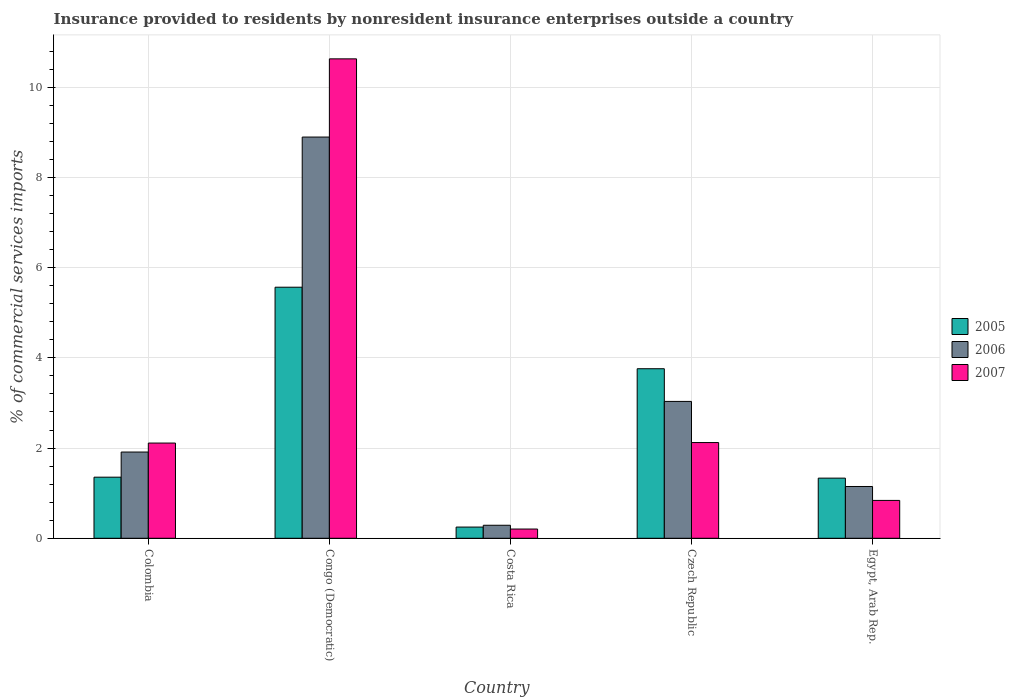How many groups of bars are there?
Provide a succinct answer. 5. Are the number of bars per tick equal to the number of legend labels?
Offer a very short reply. Yes. Are the number of bars on each tick of the X-axis equal?
Offer a very short reply. Yes. How many bars are there on the 5th tick from the right?
Provide a succinct answer. 3. What is the label of the 4th group of bars from the left?
Your answer should be compact. Czech Republic. In how many cases, is the number of bars for a given country not equal to the number of legend labels?
Your answer should be compact. 0. What is the Insurance provided to residents in 2005 in Congo (Democratic)?
Provide a short and direct response. 5.57. Across all countries, what is the maximum Insurance provided to residents in 2007?
Keep it short and to the point. 10.63. Across all countries, what is the minimum Insurance provided to residents in 2006?
Your answer should be very brief. 0.29. In which country was the Insurance provided to residents in 2005 maximum?
Keep it short and to the point. Congo (Democratic). What is the total Insurance provided to residents in 2007 in the graph?
Provide a short and direct response. 15.9. What is the difference between the Insurance provided to residents in 2007 in Congo (Democratic) and that in Egypt, Arab Rep.?
Provide a short and direct response. 9.79. What is the difference between the Insurance provided to residents in 2006 in Colombia and the Insurance provided to residents in 2005 in Czech Republic?
Offer a very short reply. -1.85. What is the average Insurance provided to residents in 2005 per country?
Offer a very short reply. 2.45. What is the difference between the Insurance provided to residents of/in 2006 and Insurance provided to residents of/in 2007 in Czech Republic?
Ensure brevity in your answer.  0.91. In how many countries, is the Insurance provided to residents in 2007 greater than 4 %?
Provide a succinct answer. 1. What is the ratio of the Insurance provided to residents in 2005 in Costa Rica to that in Egypt, Arab Rep.?
Keep it short and to the point. 0.19. Is the Insurance provided to residents in 2006 in Congo (Democratic) less than that in Czech Republic?
Ensure brevity in your answer.  No. Is the difference between the Insurance provided to residents in 2006 in Costa Rica and Egypt, Arab Rep. greater than the difference between the Insurance provided to residents in 2007 in Costa Rica and Egypt, Arab Rep.?
Offer a terse response. No. What is the difference between the highest and the second highest Insurance provided to residents in 2006?
Provide a short and direct response. 6.98. What is the difference between the highest and the lowest Insurance provided to residents in 2007?
Make the answer very short. 10.42. In how many countries, is the Insurance provided to residents in 2005 greater than the average Insurance provided to residents in 2005 taken over all countries?
Your response must be concise. 2. What does the 3rd bar from the left in Congo (Democratic) represents?
Provide a short and direct response. 2007. What does the 3rd bar from the right in Czech Republic represents?
Keep it short and to the point. 2005. Is it the case that in every country, the sum of the Insurance provided to residents in 2006 and Insurance provided to residents in 2005 is greater than the Insurance provided to residents in 2007?
Make the answer very short. Yes. Are all the bars in the graph horizontal?
Offer a very short reply. No. How many countries are there in the graph?
Offer a terse response. 5. How many legend labels are there?
Provide a short and direct response. 3. What is the title of the graph?
Ensure brevity in your answer.  Insurance provided to residents by nonresident insurance enterprises outside a country. Does "1973" appear as one of the legend labels in the graph?
Offer a very short reply. No. What is the label or title of the X-axis?
Offer a very short reply. Country. What is the label or title of the Y-axis?
Your answer should be very brief. % of commercial services imports. What is the % of commercial services imports in 2005 in Colombia?
Your answer should be compact. 1.35. What is the % of commercial services imports of 2006 in Colombia?
Your answer should be very brief. 1.91. What is the % of commercial services imports in 2007 in Colombia?
Provide a succinct answer. 2.11. What is the % of commercial services imports of 2005 in Congo (Democratic)?
Your answer should be compact. 5.57. What is the % of commercial services imports in 2006 in Congo (Democratic)?
Provide a short and direct response. 8.89. What is the % of commercial services imports in 2007 in Congo (Democratic)?
Keep it short and to the point. 10.63. What is the % of commercial services imports of 2005 in Costa Rica?
Your answer should be compact. 0.25. What is the % of commercial services imports of 2006 in Costa Rica?
Keep it short and to the point. 0.29. What is the % of commercial services imports of 2007 in Costa Rica?
Your answer should be very brief. 0.2. What is the % of commercial services imports in 2005 in Czech Republic?
Your answer should be very brief. 3.76. What is the % of commercial services imports in 2006 in Czech Republic?
Offer a terse response. 3.03. What is the % of commercial services imports in 2007 in Czech Republic?
Make the answer very short. 2.12. What is the % of commercial services imports of 2005 in Egypt, Arab Rep.?
Your answer should be very brief. 1.33. What is the % of commercial services imports in 2006 in Egypt, Arab Rep.?
Offer a terse response. 1.15. What is the % of commercial services imports of 2007 in Egypt, Arab Rep.?
Offer a terse response. 0.84. Across all countries, what is the maximum % of commercial services imports of 2005?
Your response must be concise. 5.57. Across all countries, what is the maximum % of commercial services imports in 2006?
Your answer should be very brief. 8.89. Across all countries, what is the maximum % of commercial services imports in 2007?
Your answer should be compact. 10.63. Across all countries, what is the minimum % of commercial services imports of 2005?
Your answer should be very brief. 0.25. Across all countries, what is the minimum % of commercial services imports in 2006?
Provide a short and direct response. 0.29. Across all countries, what is the minimum % of commercial services imports of 2007?
Offer a very short reply. 0.2. What is the total % of commercial services imports of 2005 in the graph?
Your response must be concise. 12.26. What is the total % of commercial services imports of 2006 in the graph?
Give a very brief answer. 15.28. What is the total % of commercial services imports in 2007 in the graph?
Your answer should be compact. 15.9. What is the difference between the % of commercial services imports in 2005 in Colombia and that in Congo (Democratic)?
Ensure brevity in your answer.  -4.21. What is the difference between the % of commercial services imports of 2006 in Colombia and that in Congo (Democratic)?
Give a very brief answer. -6.98. What is the difference between the % of commercial services imports in 2007 in Colombia and that in Congo (Democratic)?
Your response must be concise. -8.52. What is the difference between the % of commercial services imports in 2005 in Colombia and that in Costa Rica?
Your answer should be very brief. 1.11. What is the difference between the % of commercial services imports of 2006 in Colombia and that in Costa Rica?
Keep it short and to the point. 1.62. What is the difference between the % of commercial services imports in 2007 in Colombia and that in Costa Rica?
Your answer should be very brief. 1.91. What is the difference between the % of commercial services imports in 2005 in Colombia and that in Czech Republic?
Make the answer very short. -2.4. What is the difference between the % of commercial services imports of 2006 in Colombia and that in Czech Republic?
Give a very brief answer. -1.12. What is the difference between the % of commercial services imports of 2007 in Colombia and that in Czech Republic?
Provide a short and direct response. -0.01. What is the difference between the % of commercial services imports in 2005 in Colombia and that in Egypt, Arab Rep.?
Offer a very short reply. 0.02. What is the difference between the % of commercial services imports of 2006 in Colombia and that in Egypt, Arab Rep.?
Offer a terse response. 0.76. What is the difference between the % of commercial services imports in 2007 in Colombia and that in Egypt, Arab Rep.?
Your answer should be very brief. 1.27. What is the difference between the % of commercial services imports in 2005 in Congo (Democratic) and that in Costa Rica?
Provide a succinct answer. 5.32. What is the difference between the % of commercial services imports of 2006 in Congo (Democratic) and that in Costa Rica?
Ensure brevity in your answer.  8.6. What is the difference between the % of commercial services imports of 2007 in Congo (Democratic) and that in Costa Rica?
Provide a short and direct response. 10.42. What is the difference between the % of commercial services imports in 2005 in Congo (Democratic) and that in Czech Republic?
Ensure brevity in your answer.  1.81. What is the difference between the % of commercial services imports of 2006 in Congo (Democratic) and that in Czech Republic?
Your answer should be compact. 5.86. What is the difference between the % of commercial services imports of 2007 in Congo (Democratic) and that in Czech Republic?
Make the answer very short. 8.51. What is the difference between the % of commercial services imports in 2005 in Congo (Democratic) and that in Egypt, Arab Rep.?
Provide a short and direct response. 4.23. What is the difference between the % of commercial services imports of 2006 in Congo (Democratic) and that in Egypt, Arab Rep.?
Provide a succinct answer. 7.75. What is the difference between the % of commercial services imports in 2007 in Congo (Democratic) and that in Egypt, Arab Rep.?
Your response must be concise. 9.79. What is the difference between the % of commercial services imports of 2005 in Costa Rica and that in Czech Republic?
Keep it short and to the point. -3.51. What is the difference between the % of commercial services imports of 2006 in Costa Rica and that in Czech Republic?
Make the answer very short. -2.75. What is the difference between the % of commercial services imports of 2007 in Costa Rica and that in Czech Republic?
Ensure brevity in your answer.  -1.92. What is the difference between the % of commercial services imports in 2005 in Costa Rica and that in Egypt, Arab Rep.?
Give a very brief answer. -1.08. What is the difference between the % of commercial services imports in 2006 in Costa Rica and that in Egypt, Arab Rep.?
Your response must be concise. -0.86. What is the difference between the % of commercial services imports of 2007 in Costa Rica and that in Egypt, Arab Rep.?
Keep it short and to the point. -0.63. What is the difference between the % of commercial services imports in 2005 in Czech Republic and that in Egypt, Arab Rep.?
Make the answer very short. 2.42. What is the difference between the % of commercial services imports of 2006 in Czech Republic and that in Egypt, Arab Rep.?
Offer a very short reply. 1.89. What is the difference between the % of commercial services imports in 2007 in Czech Republic and that in Egypt, Arab Rep.?
Ensure brevity in your answer.  1.28. What is the difference between the % of commercial services imports of 2005 in Colombia and the % of commercial services imports of 2006 in Congo (Democratic)?
Give a very brief answer. -7.54. What is the difference between the % of commercial services imports in 2005 in Colombia and the % of commercial services imports in 2007 in Congo (Democratic)?
Make the answer very short. -9.27. What is the difference between the % of commercial services imports in 2006 in Colombia and the % of commercial services imports in 2007 in Congo (Democratic)?
Your response must be concise. -8.72. What is the difference between the % of commercial services imports of 2005 in Colombia and the % of commercial services imports of 2006 in Costa Rica?
Keep it short and to the point. 1.07. What is the difference between the % of commercial services imports of 2005 in Colombia and the % of commercial services imports of 2007 in Costa Rica?
Provide a short and direct response. 1.15. What is the difference between the % of commercial services imports of 2006 in Colombia and the % of commercial services imports of 2007 in Costa Rica?
Make the answer very short. 1.71. What is the difference between the % of commercial services imports of 2005 in Colombia and the % of commercial services imports of 2006 in Czech Republic?
Provide a short and direct response. -1.68. What is the difference between the % of commercial services imports in 2005 in Colombia and the % of commercial services imports in 2007 in Czech Republic?
Offer a very short reply. -0.77. What is the difference between the % of commercial services imports of 2006 in Colombia and the % of commercial services imports of 2007 in Czech Republic?
Offer a very short reply. -0.21. What is the difference between the % of commercial services imports of 2005 in Colombia and the % of commercial services imports of 2006 in Egypt, Arab Rep.?
Keep it short and to the point. 0.21. What is the difference between the % of commercial services imports of 2005 in Colombia and the % of commercial services imports of 2007 in Egypt, Arab Rep.?
Ensure brevity in your answer.  0.52. What is the difference between the % of commercial services imports of 2006 in Colombia and the % of commercial services imports of 2007 in Egypt, Arab Rep.?
Provide a short and direct response. 1.07. What is the difference between the % of commercial services imports of 2005 in Congo (Democratic) and the % of commercial services imports of 2006 in Costa Rica?
Your response must be concise. 5.28. What is the difference between the % of commercial services imports in 2005 in Congo (Democratic) and the % of commercial services imports in 2007 in Costa Rica?
Make the answer very short. 5.36. What is the difference between the % of commercial services imports in 2006 in Congo (Democratic) and the % of commercial services imports in 2007 in Costa Rica?
Give a very brief answer. 8.69. What is the difference between the % of commercial services imports in 2005 in Congo (Democratic) and the % of commercial services imports in 2006 in Czech Republic?
Your answer should be very brief. 2.53. What is the difference between the % of commercial services imports in 2005 in Congo (Democratic) and the % of commercial services imports in 2007 in Czech Republic?
Keep it short and to the point. 3.44. What is the difference between the % of commercial services imports in 2006 in Congo (Democratic) and the % of commercial services imports in 2007 in Czech Republic?
Provide a succinct answer. 6.77. What is the difference between the % of commercial services imports of 2005 in Congo (Democratic) and the % of commercial services imports of 2006 in Egypt, Arab Rep.?
Your response must be concise. 4.42. What is the difference between the % of commercial services imports of 2005 in Congo (Democratic) and the % of commercial services imports of 2007 in Egypt, Arab Rep.?
Your response must be concise. 4.73. What is the difference between the % of commercial services imports of 2006 in Congo (Democratic) and the % of commercial services imports of 2007 in Egypt, Arab Rep.?
Your answer should be very brief. 8.05. What is the difference between the % of commercial services imports in 2005 in Costa Rica and the % of commercial services imports in 2006 in Czech Republic?
Give a very brief answer. -2.79. What is the difference between the % of commercial services imports of 2005 in Costa Rica and the % of commercial services imports of 2007 in Czech Republic?
Your answer should be compact. -1.87. What is the difference between the % of commercial services imports of 2006 in Costa Rica and the % of commercial services imports of 2007 in Czech Republic?
Provide a short and direct response. -1.83. What is the difference between the % of commercial services imports in 2005 in Costa Rica and the % of commercial services imports in 2006 in Egypt, Arab Rep.?
Your answer should be compact. -0.9. What is the difference between the % of commercial services imports of 2005 in Costa Rica and the % of commercial services imports of 2007 in Egypt, Arab Rep.?
Provide a succinct answer. -0.59. What is the difference between the % of commercial services imports of 2006 in Costa Rica and the % of commercial services imports of 2007 in Egypt, Arab Rep.?
Give a very brief answer. -0.55. What is the difference between the % of commercial services imports of 2005 in Czech Republic and the % of commercial services imports of 2006 in Egypt, Arab Rep.?
Keep it short and to the point. 2.61. What is the difference between the % of commercial services imports of 2005 in Czech Republic and the % of commercial services imports of 2007 in Egypt, Arab Rep.?
Your answer should be very brief. 2.92. What is the difference between the % of commercial services imports in 2006 in Czech Republic and the % of commercial services imports in 2007 in Egypt, Arab Rep.?
Keep it short and to the point. 2.19. What is the average % of commercial services imports in 2005 per country?
Your answer should be very brief. 2.45. What is the average % of commercial services imports of 2006 per country?
Offer a terse response. 3.06. What is the average % of commercial services imports in 2007 per country?
Keep it short and to the point. 3.18. What is the difference between the % of commercial services imports in 2005 and % of commercial services imports in 2006 in Colombia?
Your answer should be very brief. -0.56. What is the difference between the % of commercial services imports in 2005 and % of commercial services imports in 2007 in Colombia?
Ensure brevity in your answer.  -0.76. What is the difference between the % of commercial services imports of 2006 and % of commercial services imports of 2007 in Colombia?
Ensure brevity in your answer.  -0.2. What is the difference between the % of commercial services imports of 2005 and % of commercial services imports of 2006 in Congo (Democratic)?
Provide a succinct answer. -3.33. What is the difference between the % of commercial services imports in 2005 and % of commercial services imports in 2007 in Congo (Democratic)?
Make the answer very short. -5.06. What is the difference between the % of commercial services imports in 2006 and % of commercial services imports in 2007 in Congo (Democratic)?
Give a very brief answer. -1.73. What is the difference between the % of commercial services imports in 2005 and % of commercial services imports in 2006 in Costa Rica?
Provide a short and direct response. -0.04. What is the difference between the % of commercial services imports in 2005 and % of commercial services imports in 2007 in Costa Rica?
Keep it short and to the point. 0.04. What is the difference between the % of commercial services imports of 2006 and % of commercial services imports of 2007 in Costa Rica?
Offer a very short reply. 0.08. What is the difference between the % of commercial services imports in 2005 and % of commercial services imports in 2006 in Czech Republic?
Your answer should be compact. 0.72. What is the difference between the % of commercial services imports in 2005 and % of commercial services imports in 2007 in Czech Republic?
Ensure brevity in your answer.  1.64. What is the difference between the % of commercial services imports of 2006 and % of commercial services imports of 2007 in Czech Republic?
Offer a terse response. 0.91. What is the difference between the % of commercial services imports in 2005 and % of commercial services imports in 2006 in Egypt, Arab Rep.?
Make the answer very short. 0.19. What is the difference between the % of commercial services imports of 2005 and % of commercial services imports of 2007 in Egypt, Arab Rep.?
Offer a very short reply. 0.49. What is the difference between the % of commercial services imports of 2006 and % of commercial services imports of 2007 in Egypt, Arab Rep.?
Give a very brief answer. 0.31. What is the ratio of the % of commercial services imports in 2005 in Colombia to that in Congo (Democratic)?
Your answer should be very brief. 0.24. What is the ratio of the % of commercial services imports in 2006 in Colombia to that in Congo (Democratic)?
Your answer should be compact. 0.21. What is the ratio of the % of commercial services imports of 2007 in Colombia to that in Congo (Democratic)?
Your answer should be very brief. 0.2. What is the ratio of the % of commercial services imports of 2005 in Colombia to that in Costa Rica?
Make the answer very short. 5.45. What is the ratio of the % of commercial services imports in 2006 in Colombia to that in Costa Rica?
Your answer should be compact. 6.62. What is the ratio of the % of commercial services imports in 2007 in Colombia to that in Costa Rica?
Make the answer very short. 10.3. What is the ratio of the % of commercial services imports of 2005 in Colombia to that in Czech Republic?
Keep it short and to the point. 0.36. What is the ratio of the % of commercial services imports in 2006 in Colombia to that in Czech Republic?
Keep it short and to the point. 0.63. What is the ratio of the % of commercial services imports in 2007 in Colombia to that in Czech Republic?
Provide a succinct answer. 0.99. What is the ratio of the % of commercial services imports in 2005 in Colombia to that in Egypt, Arab Rep.?
Your answer should be compact. 1.02. What is the ratio of the % of commercial services imports in 2006 in Colombia to that in Egypt, Arab Rep.?
Your answer should be very brief. 1.67. What is the ratio of the % of commercial services imports in 2007 in Colombia to that in Egypt, Arab Rep.?
Keep it short and to the point. 2.51. What is the ratio of the % of commercial services imports in 2005 in Congo (Democratic) to that in Costa Rica?
Your response must be concise. 22.41. What is the ratio of the % of commercial services imports in 2006 in Congo (Democratic) to that in Costa Rica?
Offer a terse response. 30.8. What is the ratio of the % of commercial services imports in 2007 in Congo (Democratic) to that in Costa Rica?
Your response must be concise. 51.87. What is the ratio of the % of commercial services imports of 2005 in Congo (Democratic) to that in Czech Republic?
Offer a very short reply. 1.48. What is the ratio of the % of commercial services imports of 2006 in Congo (Democratic) to that in Czech Republic?
Give a very brief answer. 2.93. What is the ratio of the % of commercial services imports of 2007 in Congo (Democratic) to that in Czech Republic?
Offer a terse response. 5.01. What is the ratio of the % of commercial services imports in 2005 in Congo (Democratic) to that in Egypt, Arab Rep.?
Keep it short and to the point. 4.17. What is the ratio of the % of commercial services imports of 2006 in Congo (Democratic) to that in Egypt, Arab Rep.?
Your response must be concise. 7.75. What is the ratio of the % of commercial services imports in 2007 in Congo (Democratic) to that in Egypt, Arab Rep.?
Provide a succinct answer. 12.66. What is the ratio of the % of commercial services imports of 2005 in Costa Rica to that in Czech Republic?
Keep it short and to the point. 0.07. What is the ratio of the % of commercial services imports in 2006 in Costa Rica to that in Czech Republic?
Your answer should be compact. 0.1. What is the ratio of the % of commercial services imports in 2007 in Costa Rica to that in Czech Republic?
Offer a very short reply. 0.1. What is the ratio of the % of commercial services imports in 2005 in Costa Rica to that in Egypt, Arab Rep.?
Your response must be concise. 0.19. What is the ratio of the % of commercial services imports of 2006 in Costa Rica to that in Egypt, Arab Rep.?
Provide a short and direct response. 0.25. What is the ratio of the % of commercial services imports in 2007 in Costa Rica to that in Egypt, Arab Rep.?
Keep it short and to the point. 0.24. What is the ratio of the % of commercial services imports in 2005 in Czech Republic to that in Egypt, Arab Rep.?
Your answer should be compact. 2.82. What is the ratio of the % of commercial services imports of 2006 in Czech Republic to that in Egypt, Arab Rep.?
Your answer should be very brief. 2.64. What is the ratio of the % of commercial services imports of 2007 in Czech Republic to that in Egypt, Arab Rep.?
Ensure brevity in your answer.  2.53. What is the difference between the highest and the second highest % of commercial services imports of 2005?
Make the answer very short. 1.81. What is the difference between the highest and the second highest % of commercial services imports in 2006?
Ensure brevity in your answer.  5.86. What is the difference between the highest and the second highest % of commercial services imports in 2007?
Provide a succinct answer. 8.51. What is the difference between the highest and the lowest % of commercial services imports of 2005?
Provide a succinct answer. 5.32. What is the difference between the highest and the lowest % of commercial services imports of 2006?
Keep it short and to the point. 8.6. What is the difference between the highest and the lowest % of commercial services imports in 2007?
Give a very brief answer. 10.42. 